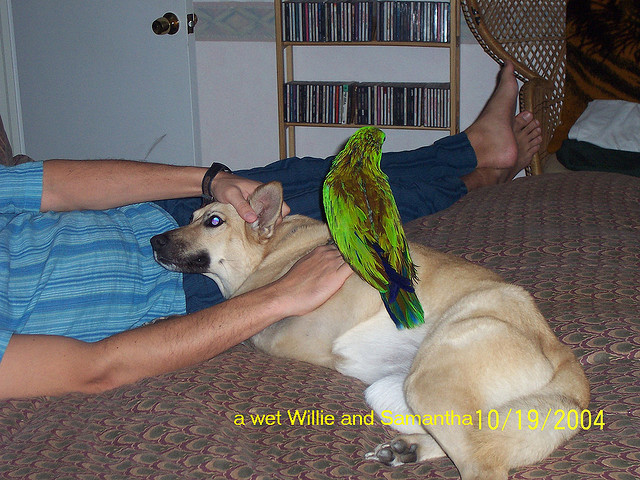Identify the text displayed in this image. Wet a Willie and samantha 2004 19 10 